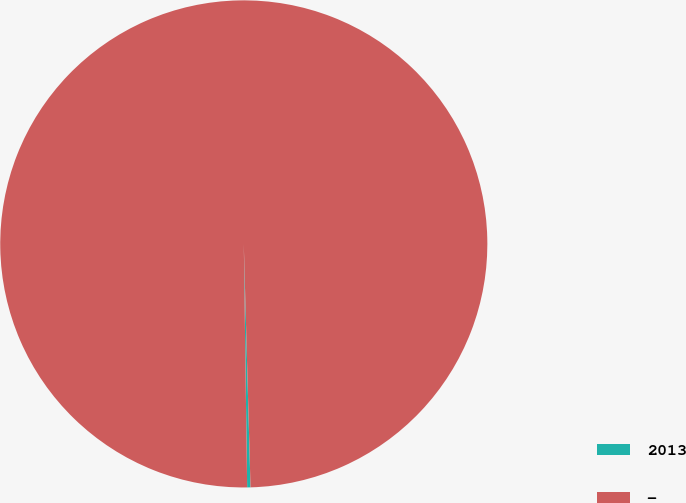<chart> <loc_0><loc_0><loc_500><loc_500><pie_chart><fcel>2013<fcel>-<nl><fcel>0.22%<fcel>99.78%<nl></chart> 